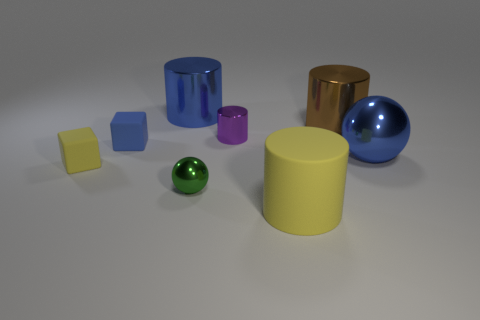There is a cylinder that is the same color as the big ball; what material is it?
Provide a short and direct response. Metal. How many cubes are either small metallic things or matte things?
Give a very brief answer. 2. The matte cylinder that is the same size as the blue sphere is what color?
Give a very brief answer. Yellow. Are there any other things that have the same shape as the small yellow object?
Provide a succinct answer. Yes. There is another small rubber object that is the same shape as the small yellow object; what is its color?
Your answer should be very brief. Blue. What number of things are small things or small rubber things that are behind the tiny yellow thing?
Offer a very short reply. 4. Is the number of yellow rubber cylinders in front of the tiny ball less than the number of small purple cylinders?
Give a very brief answer. No. There is a blue thing that is behind the metal cylinder that is right of the small object behind the small blue matte thing; what size is it?
Provide a short and direct response. Large. There is a object that is both to the right of the large yellow rubber object and left of the big blue sphere; what is its color?
Make the answer very short. Brown. What number of blue matte objects are there?
Offer a terse response. 1. 